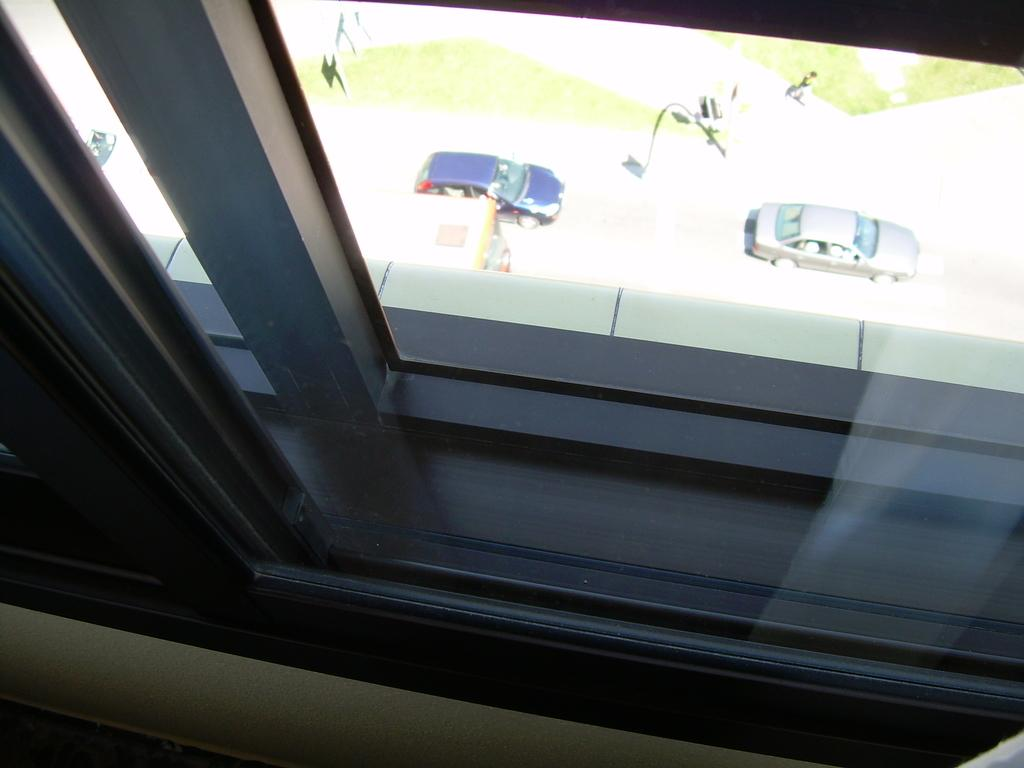What type of structure can be seen in the image? There is a glass window in the image. What can be observed on the road in the image? Vehicles are visible on the road in the image. What type of smell is emanating from the fowl in the image? There is no fowl present in the image, so it is not possible to determine any associated smells. 